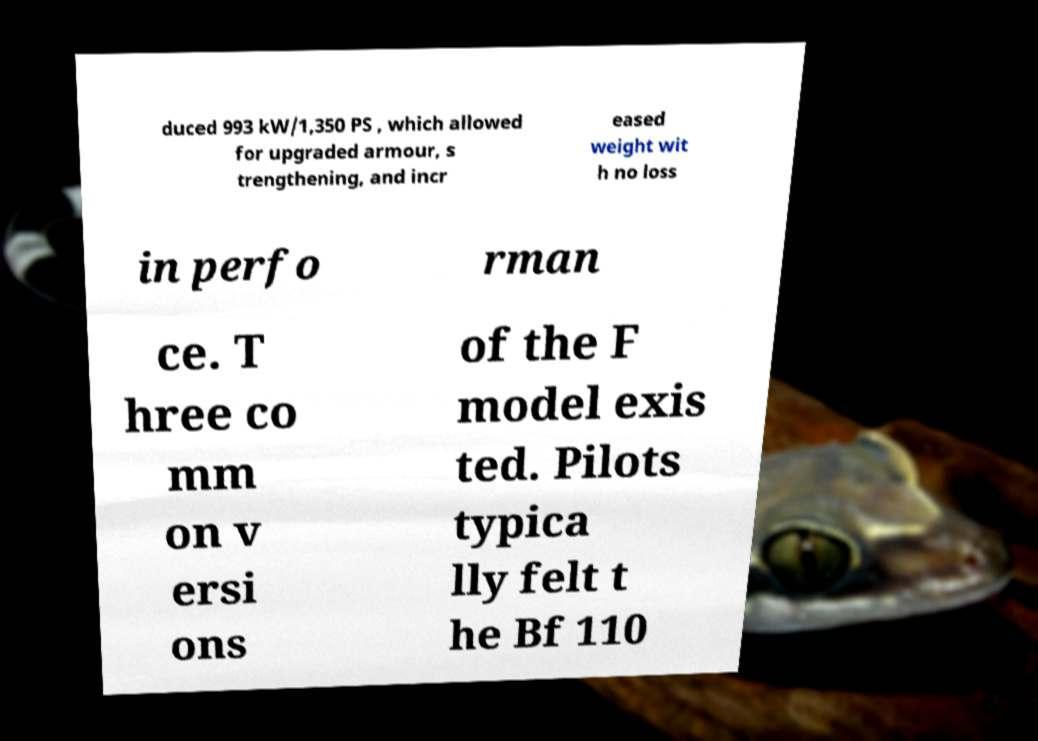There's text embedded in this image that I need extracted. Can you transcribe it verbatim? duced 993 kW/1,350 PS , which allowed for upgraded armour, s trengthening, and incr eased weight wit h no loss in perfo rman ce. T hree co mm on v ersi ons of the F model exis ted. Pilots typica lly felt t he Bf 110 